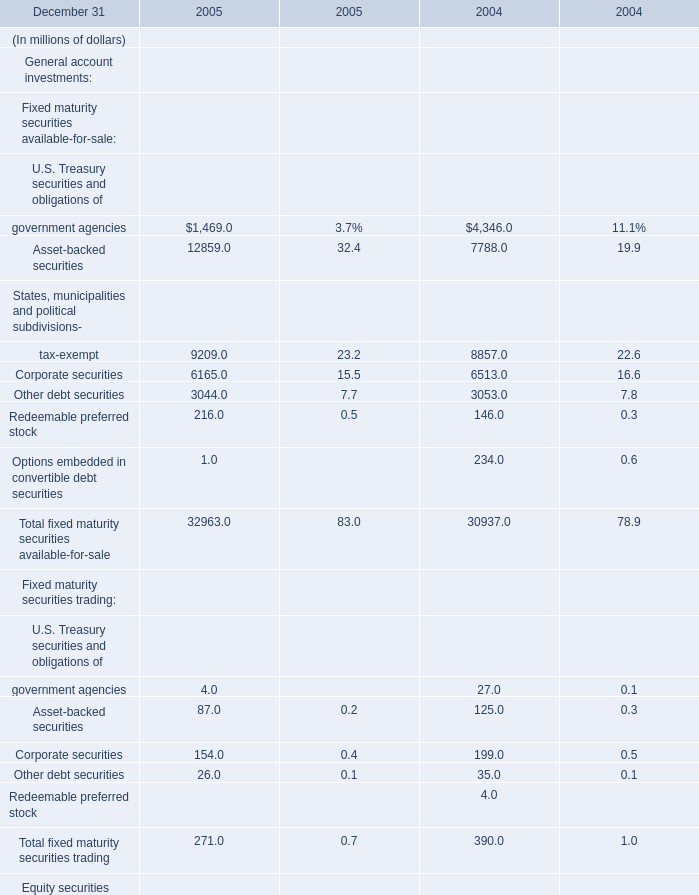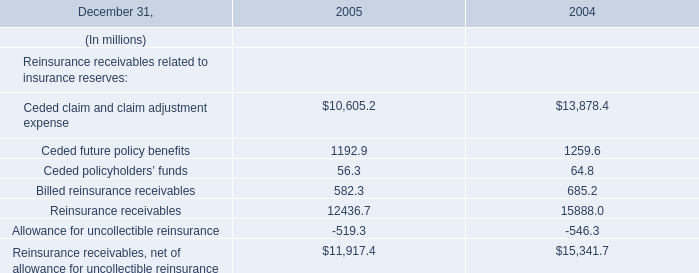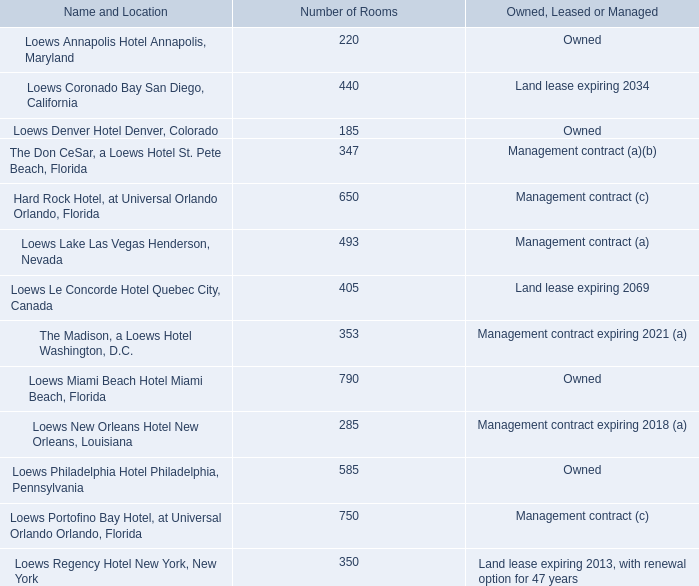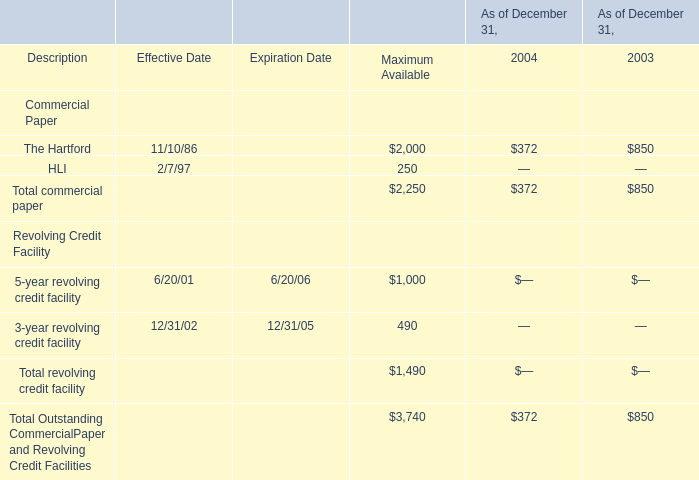What is the growing rate of Total commercial paper in the year with the most The Hartford? 
Computations: ((372 - 850) / 850)
Answer: -0.56235. 